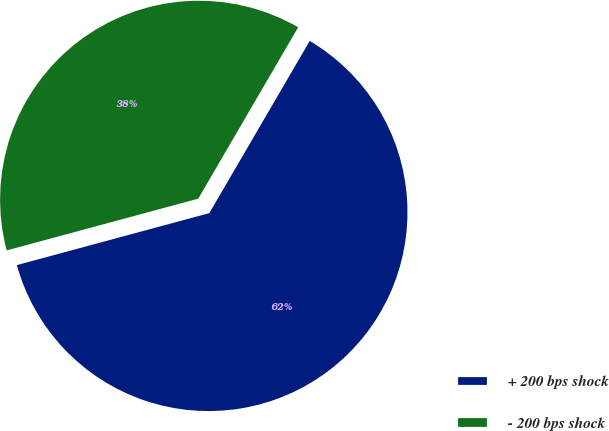Convert chart. <chart><loc_0><loc_0><loc_500><loc_500><pie_chart><fcel>+ 200 bps shock<fcel>- 200 bps shock<nl><fcel>62.4%<fcel>37.6%<nl></chart> 